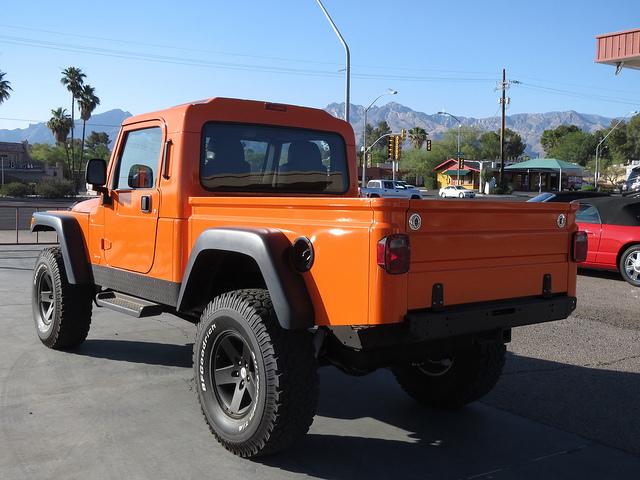What color is the center truck?
Answer briefly. Orange. How tall is the truck?
Keep it brief. 5 feet. What color is this truck?
Quick response, please. Orange. What are the vehicles parked on?
Short answer required. Asphalt. Are there mountains in the background?
Quick response, please. Yes. 